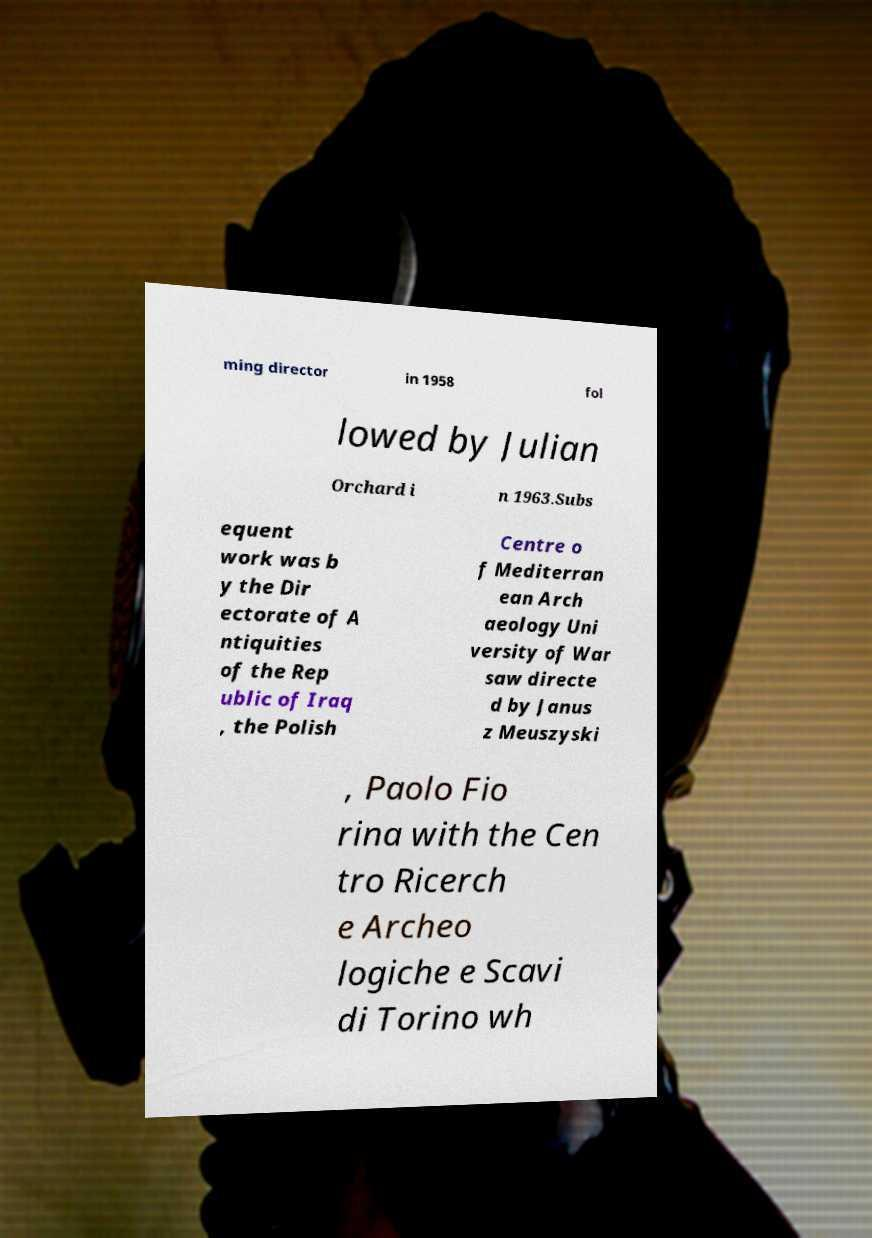For documentation purposes, I need the text within this image transcribed. Could you provide that? ming director in 1958 fol lowed by Julian Orchard i n 1963.Subs equent work was b y the Dir ectorate of A ntiquities of the Rep ublic of Iraq , the Polish Centre o f Mediterran ean Arch aeology Uni versity of War saw directe d by Janus z Meuszyski , Paolo Fio rina with the Cen tro Ricerch e Archeo logiche e Scavi di Torino wh 